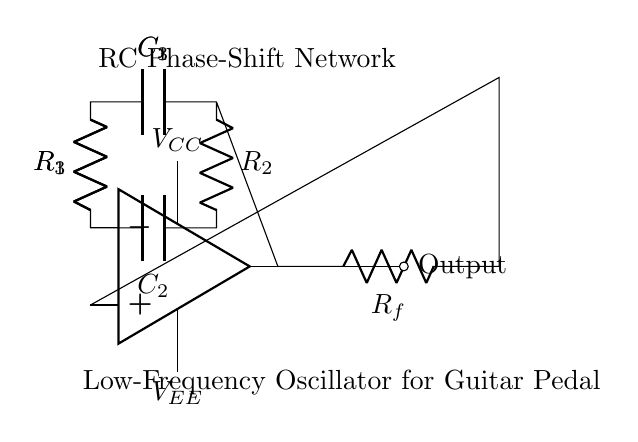What type of amplifier is used in this circuit? The circuit uses an operational amplifier, indicated by the symbol shown in the diagram.
Answer: operational amplifier What is the function of the RC network in this oscillator? The RC network, composed of resistors and capacitors, is designed to create phase shifts necessary for oscillation. Each stage provides a certain phase shift, contributing to the overall feedback loop.
Answer: create phase shifts How many resistors are present in the circuit? There are four resistors visible in the circuit: R1, R2, R3, and Rf.
Answer: four What is the purpose of the feedback resistor Rf? The feedback resistor Rf helps control the gain of the oscillator, determining the feedback ratio that stabilizes oscillation at a desired frequency.
Answer: control gain What is the frequency-determining component in this oscillator? The frequency-determining components in this RC phase-shift oscillator are the resistors and capacitors in the RC network, which collectively set the oscillation frequency based on their values.
Answer: resistors and capacitors What is the output label indicating in the circuit? The output label indicates the point where the oscillating signal can be taken out for further use, such as sending it to a guitar pedal or other audio processing equipment.
Answer: oscillating signal output What is the function of the capacitors in the RC network? The capacitors serve to store and release energy, creating the necessary timing characteristics that allow for the desired low-frequency oscillation.
Answer: store and release energy 